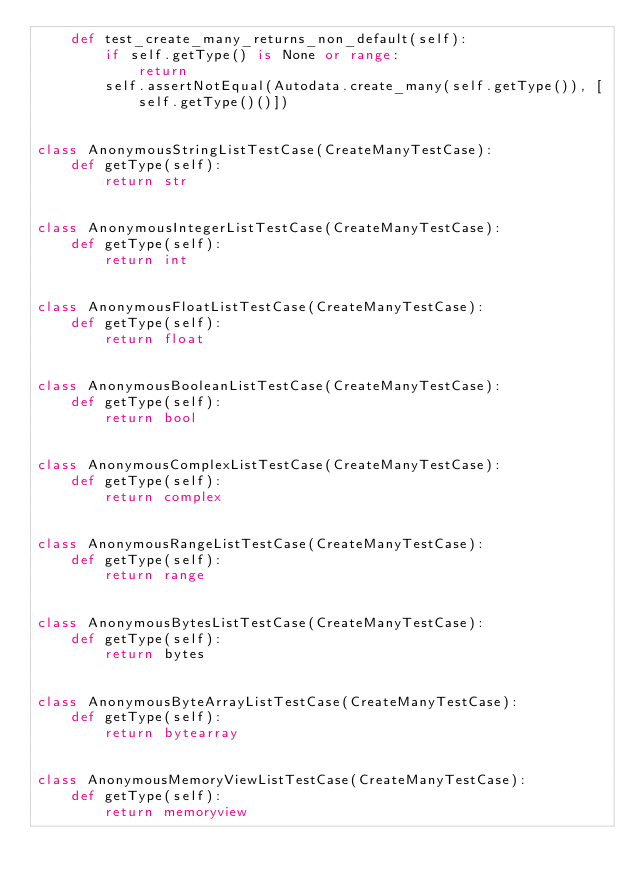<code> <loc_0><loc_0><loc_500><loc_500><_Python_>    def test_create_many_returns_non_default(self):
        if self.getType() is None or range:
            return
        self.assertNotEqual(Autodata.create_many(self.getType()), [self.getType()()])


class AnonymousStringListTestCase(CreateManyTestCase):
    def getType(self):
        return str


class AnonymousIntegerListTestCase(CreateManyTestCase):
    def getType(self):
        return int


class AnonymousFloatListTestCase(CreateManyTestCase):
    def getType(self):
        return float


class AnonymousBooleanListTestCase(CreateManyTestCase):
    def getType(self):
        return bool


class AnonymousComplexListTestCase(CreateManyTestCase):
    def getType(self):
        return complex


class AnonymousRangeListTestCase(CreateManyTestCase):
    def getType(self):
        return range


class AnonymousBytesListTestCase(CreateManyTestCase):
    def getType(self):
        return bytes


class AnonymousByteArrayListTestCase(CreateManyTestCase):
    def getType(self):
        return bytearray


class AnonymousMemoryViewListTestCase(CreateManyTestCase):
    def getType(self):
        return memoryview
</code> 